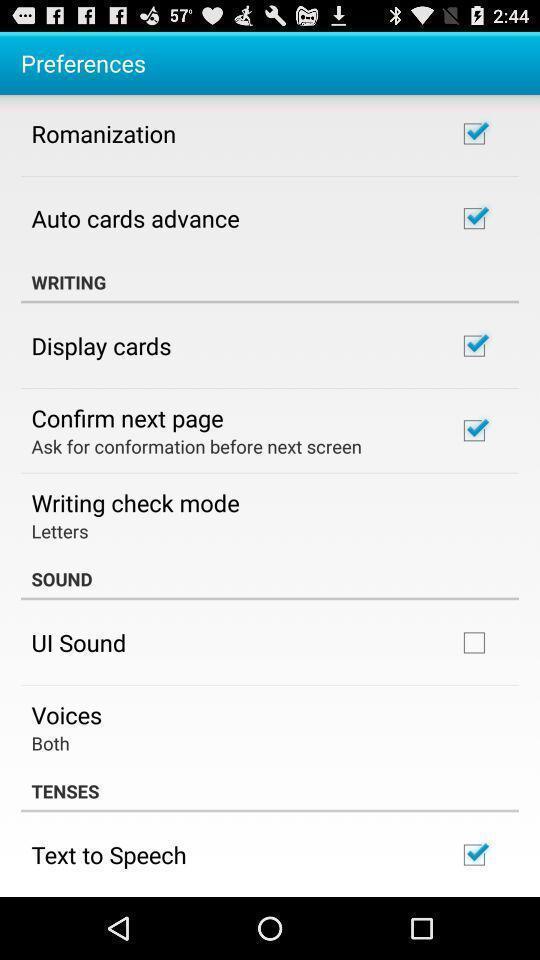Provide a textual representation of this image. Screen showing preferences page for an app. 